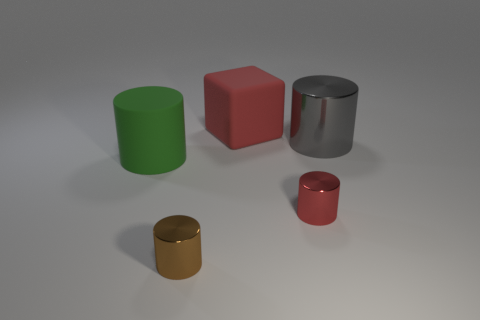Subtract all gray cylinders. How many cylinders are left? 3 Subtract 2 cylinders. How many cylinders are left? 2 Subtract all green cylinders. How many cylinders are left? 3 Add 3 large red rubber blocks. How many objects exist? 8 Subtract all blocks. How many objects are left? 4 Subtract all green cylinders. Subtract all yellow cubes. How many cylinders are left? 3 Add 5 large green cylinders. How many large green cylinders are left? 6 Add 5 big gray cylinders. How many big gray cylinders exist? 6 Subtract 0 cyan spheres. How many objects are left? 5 Subtract all large red metal blocks. Subtract all matte cylinders. How many objects are left? 4 